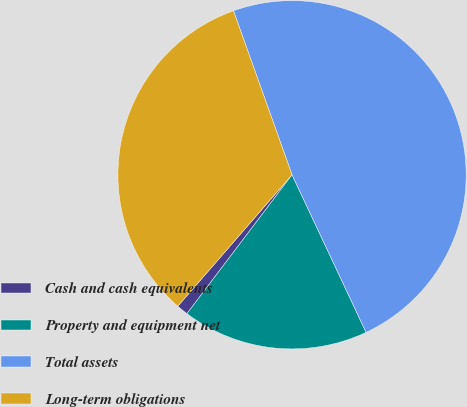<chart> <loc_0><loc_0><loc_500><loc_500><pie_chart><fcel>Cash and cash equivalents<fcel>Property and equipment net<fcel>Total assets<fcel>Long-term obligations<nl><fcel>1.08%<fcel>17.3%<fcel>48.47%<fcel>33.15%<nl></chart> 